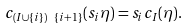Convert formula to latex. <formula><loc_0><loc_0><loc_500><loc_500>c _ { ( I \cup \{ i \} ) \ \{ i + 1 \} } ( s _ { i } \eta ) = s _ { i } c _ { I } ( \eta ) .</formula> 